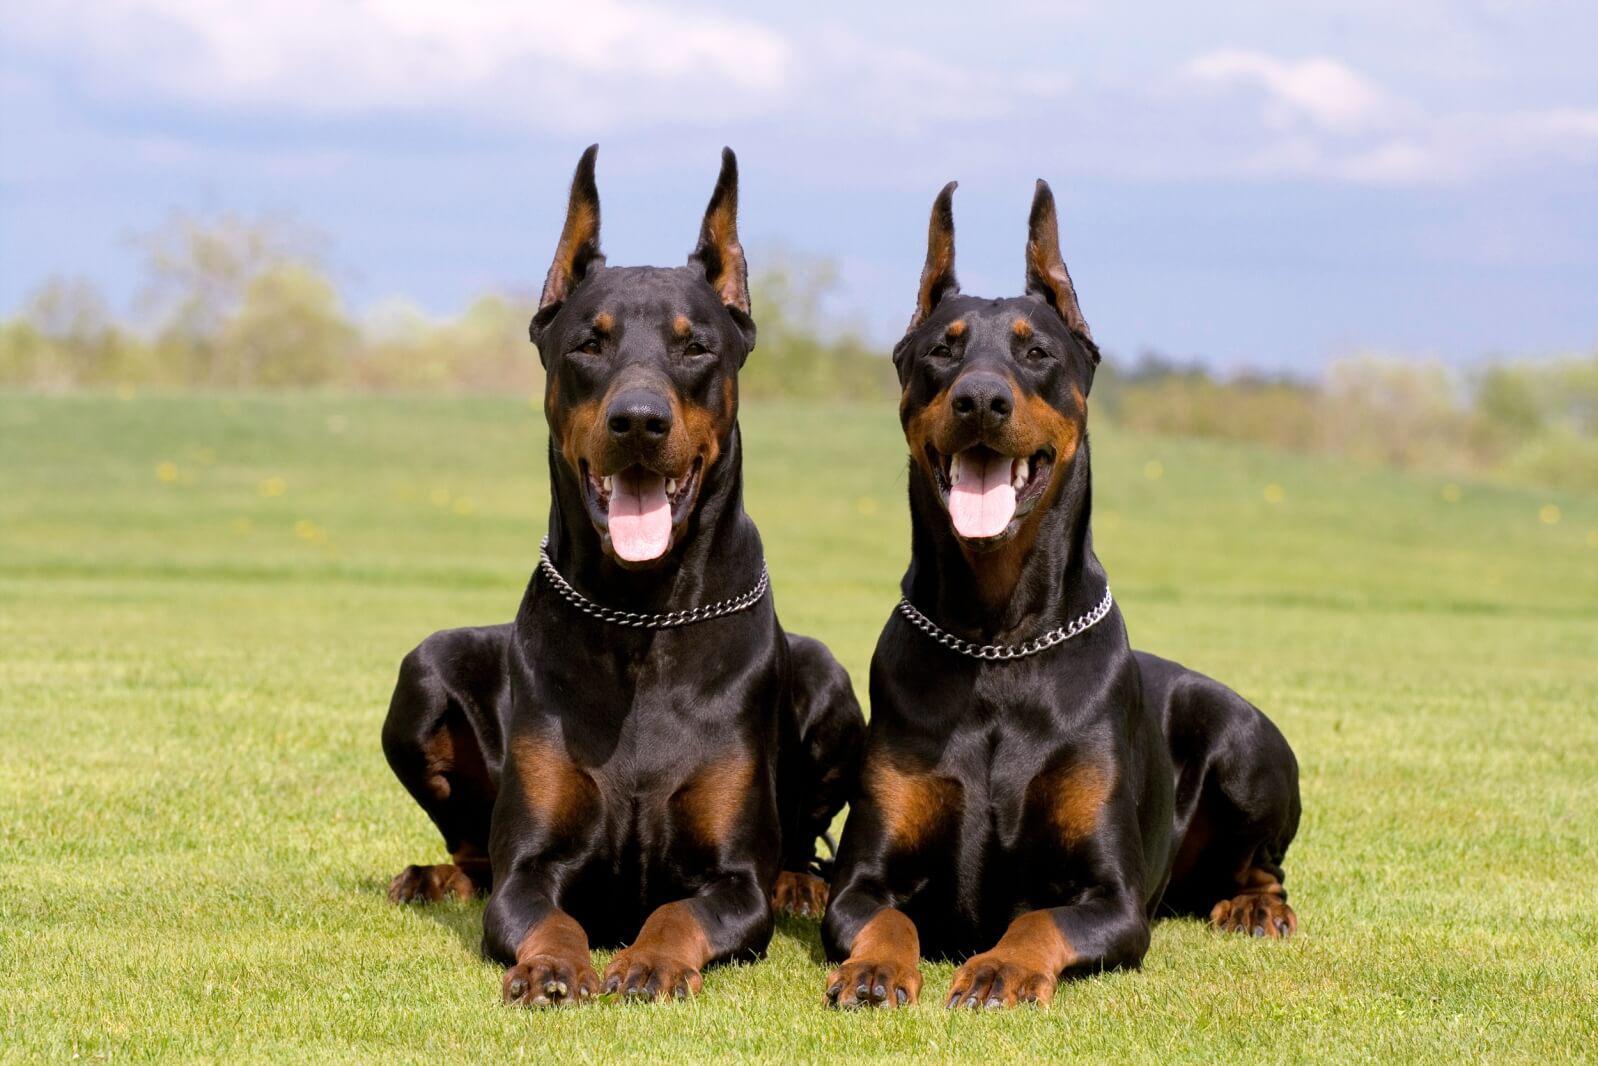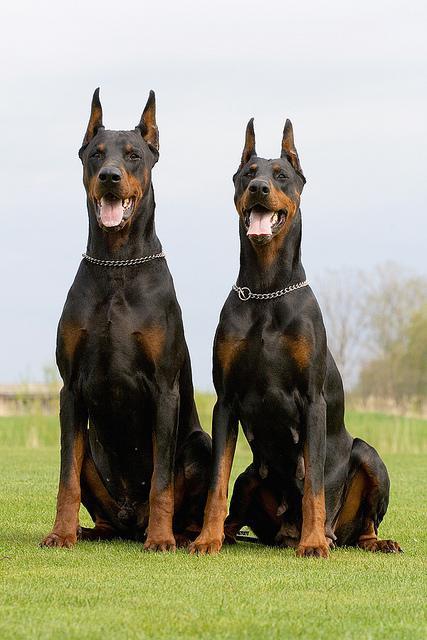The first image is the image on the left, the second image is the image on the right. Assess this claim about the two images: "One image contains two dobermans sitting upright side-by side, and the other image features two dobermans reclining side-by-side.". Correct or not? Answer yes or no. Yes. The first image is the image on the left, the second image is the image on the right. Examine the images to the left and right. Is the description "At least one dog has its mouth open in one picture and none do in the other." accurate? Answer yes or no. No. 